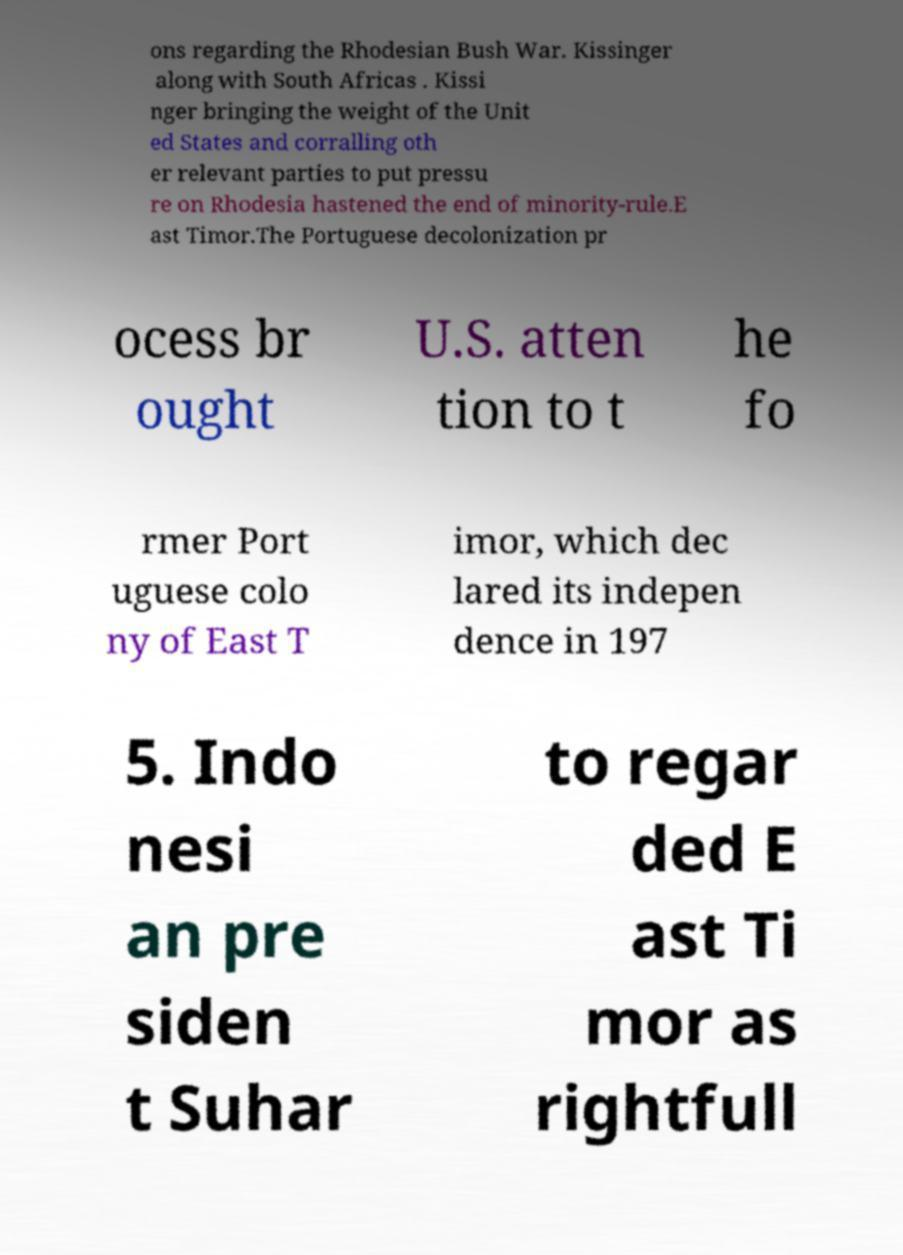What messages or text are displayed in this image? I need them in a readable, typed format. ons regarding the Rhodesian Bush War. Kissinger along with South Africas . Kissi nger bringing the weight of the Unit ed States and corralling oth er relevant parties to put pressu re on Rhodesia hastened the end of minority-rule.E ast Timor.The Portuguese decolonization pr ocess br ought U.S. atten tion to t he fo rmer Port uguese colo ny of East T imor, which dec lared its indepen dence in 197 5. Indo nesi an pre siden t Suhar to regar ded E ast Ti mor as rightfull 